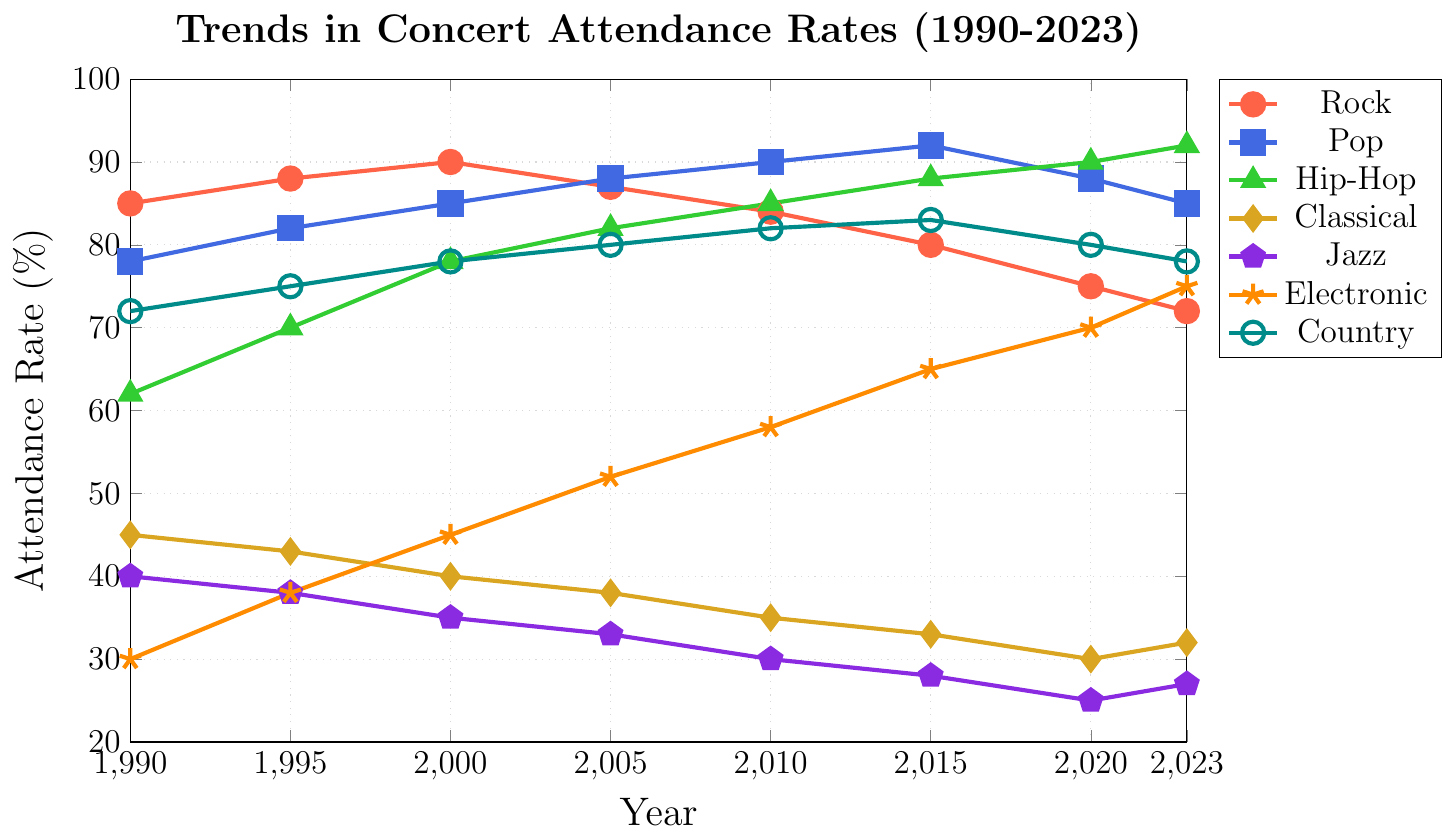Which genre had the highest concert attendance rate in 2023? Look for the highest point on the 2023 vertical line and identify its corresponding genre. Hip-Hop has the highest attendance rate at 92% in 2023.
Answer: Hip-Hop How did the attendance rate for Jazz change from 1990 to 2023? To determine the change, subtract the 1990 attendance rate from the 2023 rate. Jazz attendance decreased from 40% in 1990 to 27% in 2023 (40 - 27 = 13).
Answer: Decreased by 13 points Which year saw the highest attendance rate for Classical music, and what was the rate? Look for the highest point for Classical music across all years and note the year and the rate. The highest attendance rate for Classical music was in 1990 at 45%.
Answer: 1990, 45% What are the attendance trends for Electronic music from 1990 to 2023? Review the plot for Electronic music and observe how it changes over the years. The trend for Electronic music shows a steady increase from 30% in 1990 to 75% in 2023.
Answer: Steady increase In which year did Rock music attendance peak, and at what percentage? Identify the point with the highest attendance rate for Rock music and note the year. Rock music attendance peaked in 2000 at 90%.
Answer: 2000, 90% Compare the attendance rates of Pop and Rock music in 2005. Which genre had higher attendance, and by how much? Check the values for both genres in 2005. Pop had 88% while Rock had 87%. (88 - 87 = 1)
Answer: Pop, by 1 point Calculate the average attendance for Country music from 1990 to 2023. Sum the attendance rates for each recorded year and divide by the number of data points: (72+75+78+80+82+83+80+78)/8 = 78.5
Answer: 78.5% Between which two consecutive years did Hip-Hop music see the greatest increase in attendance? Examine adjacent points for Hip-Hop to find the pair of years with the largest positive difference. The greatest increase for Hip-Hop was between 1995 and 2000 (78 - 70 = 8).
Answer: 1995-2000, by 8 points What is the difference in attendance rates between the highest and lowest attended genres in 2023? Identify the highest (Hip-Hop, 92%) and lowest (Jazz, 27%) attendance rates for 2023. Calculate the difference (92 - 27 = 65).
Answer: 65 points 